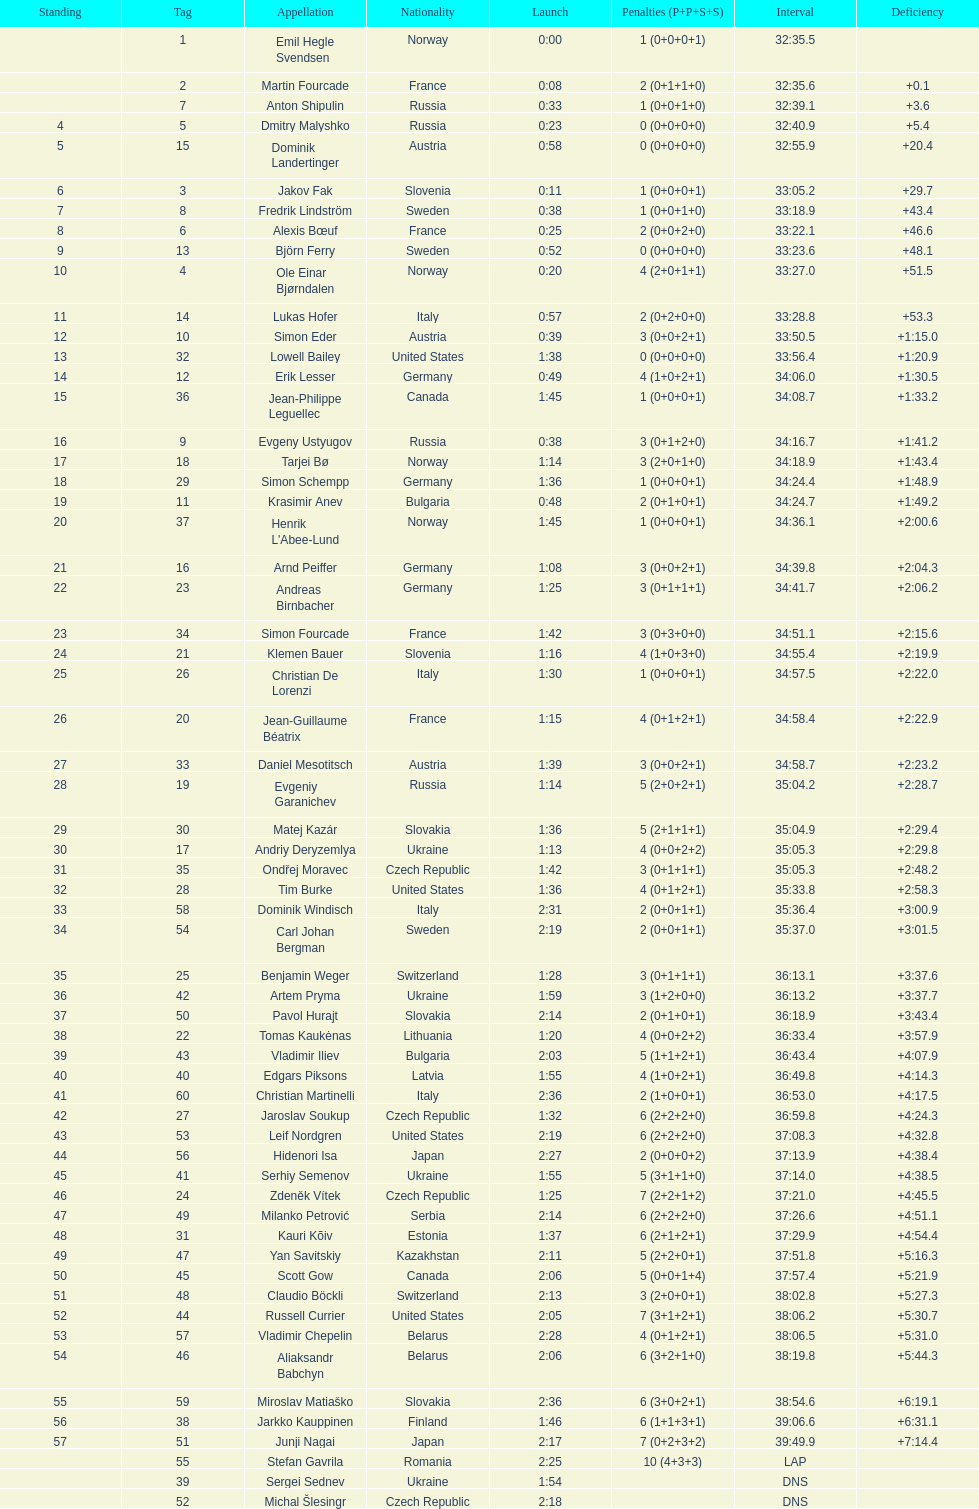How many took at least 35:00 to finish? 30. 